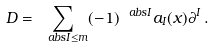Convert formula to latex. <formula><loc_0><loc_0><loc_500><loc_500>D = \sum _ { \ a b s { I } \leq m } ( - 1 ) ^ { \ a b s { I } } a _ { I } ( x ) \partial ^ { I } \, .</formula> 